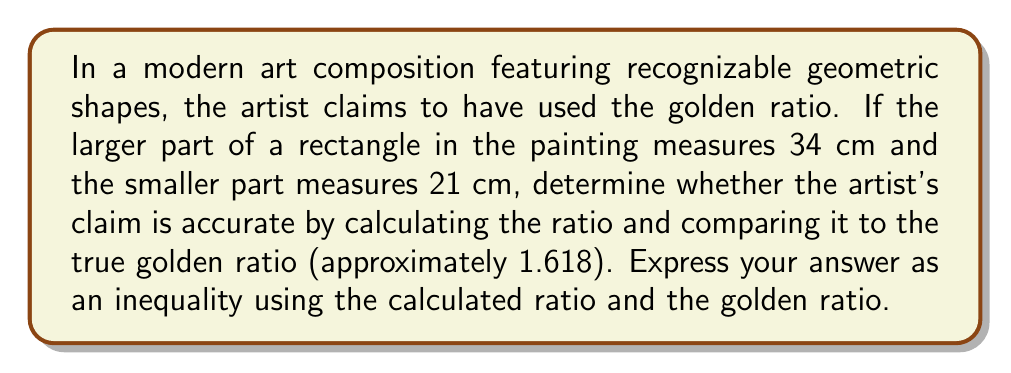Can you solve this math problem? Let's approach this step-by-step:

1) The golden ratio, denoted by $\phi$ (phi), is approximately 1.618.

2) In a golden ratio, the ratio of the larger part to the smaller part is equal to the ratio of the whole to the larger part.

3) In this case, we have:
   Larger part (a) = 34 cm
   Smaller part (b) = 21 cm

4) Let's calculate the ratio of the larger part to the smaller part:

   $$\frac{a}{b} = \frac{34}{21}$$

5) To simplify this fraction, we can divide both numerator and denominator by their greatest common divisor (GCD). The GCD of 34 and 21 is 1, so this fraction cannot be simplified further.

6) Let's perform the division:

   $$\frac{34}{21} \approx 1.619047619$$

7) Now, we need to compare this to the golden ratio ($\phi \approx 1.618$):

   1.619047619 > 1.618

8) The calculated ratio is slightly greater than the golden ratio.

9) We can express this as an inequality:

   $$\frac{34}{21} > \phi$$

This inequality shows that the ratio in the painting is very close to, but slightly exceeds, the golden ratio.
Answer: $$\frac{34}{21} > \phi$$ 